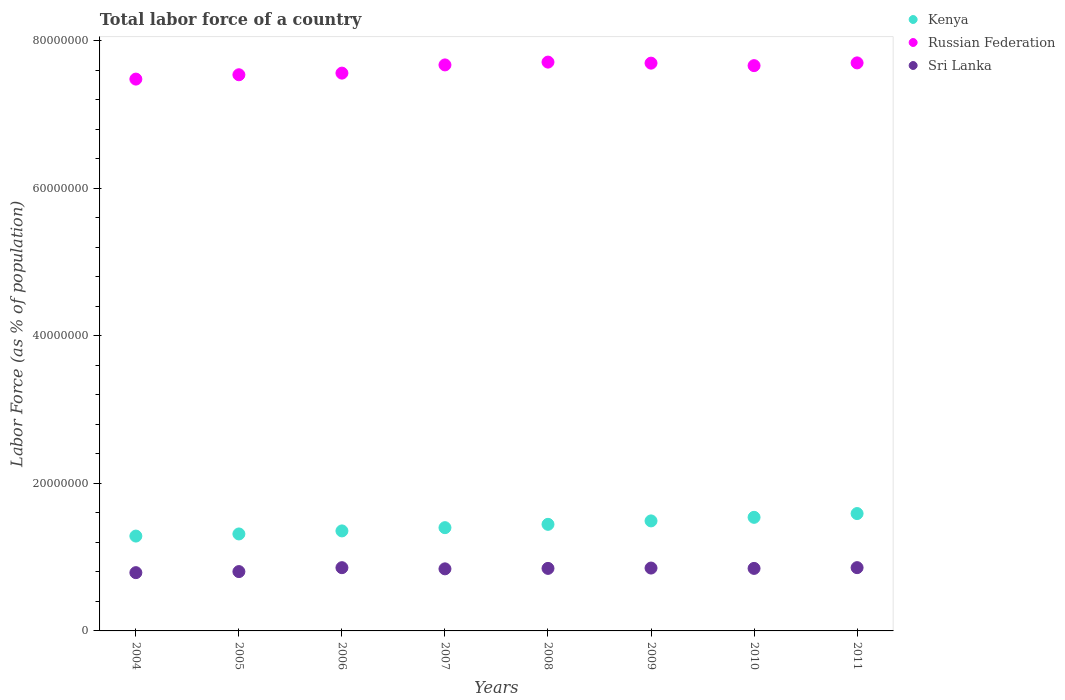How many different coloured dotlines are there?
Your answer should be compact. 3. What is the percentage of labor force in Sri Lanka in 2008?
Your response must be concise. 8.47e+06. Across all years, what is the maximum percentage of labor force in Russian Federation?
Offer a terse response. 7.71e+07. Across all years, what is the minimum percentage of labor force in Sri Lanka?
Your response must be concise. 7.90e+06. What is the total percentage of labor force in Sri Lanka in the graph?
Give a very brief answer. 6.70e+07. What is the difference between the percentage of labor force in Kenya in 2008 and that in 2009?
Offer a terse response. -4.65e+05. What is the difference between the percentage of labor force in Kenya in 2006 and the percentage of labor force in Russian Federation in 2009?
Ensure brevity in your answer.  -6.34e+07. What is the average percentage of labor force in Russian Federation per year?
Give a very brief answer. 7.62e+07. In the year 2011, what is the difference between the percentage of labor force in Kenya and percentage of labor force in Sri Lanka?
Your answer should be compact. 7.33e+06. In how many years, is the percentage of labor force in Sri Lanka greater than 4000000 %?
Provide a short and direct response. 8. What is the ratio of the percentage of labor force in Kenya in 2006 to that in 2007?
Offer a terse response. 0.97. Is the percentage of labor force in Sri Lanka in 2006 less than that in 2010?
Provide a succinct answer. No. Is the difference between the percentage of labor force in Kenya in 2004 and 2008 greater than the difference between the percentage of labor force in Sri Lanka in 2004 and 2008?
Your response must be concise. No. What is the difference between the highest and the second highest percentage of labor force in Russian Federation?
Your answer should be very brief. 1.08e+05. What is the difference between the highest and the lowest percentage of labor force in Russian Federation?
Your answer should be compact. 2.30e+06. Is the sum of the percentage of labor force in Sri Lanka in 2004 and 2011 greater than the maximum percentage of labor force in Kenya across all years?
Offer a terse response. Yes. Is it the case that in every year, the sum of the percentage of labor force in Kenya and percentage of labor force in Sri Lanka  is greater than the percentage of labor force in Russian Federation?
Provide a short and direct response. No. Does the percentage of labor force in Sri Lanka monotonically increase over the years?
Provide a succinct answer. No. Is the percentage of labor force in Russian Federation strictly greater than the percentage of labor force in Kenya over the years?
Make the answer very short. Yes. Is the percentage of labor force in Kenya strictly less than the percentage of labor force in Sri Lanka over the years?
Make the answer very short. No. How many dotlines are there?
Ensure brevity in your answer.  3. How many years are there in the graph?
Provide a succinct answer. 8. Are the values on the major ticks of Y-axis written in scientific E-notation?
Give a very brief answer. No. Does the graph contain any zero values?
Give a very brief answer. No. Does the graph contain grids?
Your answer should be very brief. No. How many legend labels are there?
Your response must be concise. 3. How are the legend labels stacked?
Provide a short and direct response. Vertical. What is the title of the graph?
Provide a short and direct response. Total labor force of a country. What is the label or title of the X-axis?
Your answer should be compact. Years. What is the label or title of the Y-axis?
Keep it short and to the point. Labor Force (as % of population). What is the Labor Force (as % of population) of Kenya in 2004?
Your answer should be very brief. 1.29e+07. What is the Labor Force (as % of population) of Russian Federation in 2004?
Make the answer very short. 7.48e+07. What is the Labor Force (as % of population) in Sri Lanka in 2004?
Make the answer very short. 7.90e+06. What is the Labor Force (as % of population) of Kenya in 2005?
Your answer should be compact. 1.31e+07. What is the Labor Force (as % of population) in Russian Federation in 2005?
Ensure brevity in your answer.  7.54e+07. What is the Labor Force (as % of population) of Sri Lanka in 2005?
Provide a succinct answer. 8.04e+06. What is the Labor Force (as % of population) in Kenya in 2006?
Ensure brevity in your answer.  1.36e+07. What is the Labor Force (as % of population) in Russian Federation in 2006?
Make the answer very short. 7.56e+07. What is the Labor Force (as % of population) in Sri Lanka in 2006?
Your response must be concise. 8.57e+06. What is the Labor Force (as % of population) of Kenya in 2007?
Give a very brief answer. 1.40e+07. What is the Labor Force (as % of population) in Russian Federation in 2007?
Ensure brevity in your answer.  7.67e+07. What is the Labor Force (as % of population) in Sri Lanka in 2007?
Your answer should be compact. 8.41e+06. What is the Labor Force (as % of population) in Kenya in 2008?
Provide a short and direct response. 1.44e+07. What is the Labor Force (as % of population) in Russian Federation in 2008?
Your answer should be very brief. 7.71e+07. What is the Labor Force (as % of population) in Sri Lanka in 2008?
Your answer should be very brief. 8.47e+06. What is the Labor Force (as % of population) of Kenya in 2009?
Provide a succinct answer. 1.49e+07. What is the Labor Force (as % of population) of Russian Federation in 2009?
Offer a terse response. 7.69e+07. What is the Labor Force (as % of population) in Sri Lanka in 2009?
Provide a succinct answer. 8.52e+06. What is the Labor Force (as % of population) of Kenya in 2010?
Your response must be concise. 1.54e+07. What is the Labor Force (as % of population) in Russian Federation in 2010?
Provide a succinct answer. 7.66e+07. What is the Labor Force (as % of population) of Sri Lanka in 2010?
Offer a terse response. 8.47e+06. What is the Labor Force (as % of population) in Kenya in 2011?
Provide a short and direct response. 1.59e+07. What is the Labor Force (as % of population) of Russian Federation in 2011?
Offer a terse response. 7.70e+07. What is the Labor Force (as % of population) of Sri Lanka in 2011?
Provide a short and direct response. 8.57e+06. Across all years, what is the maximum Labor Force (as % of population) of Kenya?
Offer a terse response. 1.59e+07. Across all years, what is the maximum Labor Force (as % of population) of Russian Federation?
Ensure brevity in your answer.  7.71e+07. Across all years, what is the maximum Labor Force (as % of population) in Sri Lanka?
Make the answer very short. 8.57e+06. Across all years, what is the minimum Labor Force (as % of population) of Kenya?
Your answer should be compact. 1.29e+07. Across all years, what is the minimum Labor Force (as % of population) of Russian Federation?
Offer a very short reply. 7.48e+07. Across all years, what is the minimum Labor Force (as % of population) of Sri Lanka?
Offer a terse response. 7.90e+06. What is the total Labor Force (as % of population) of Kenya in the graph?
Your response must be concise. 1.14e+08. What is the total Labor Force (as % of population) of Russian Federation in the graph?
Ensure brevity in your answer.  6.10e+08. What is the total Labor Force (as % of population) in Sri Lanka in the graph?
Make the answer very short. 6.70e+07. What is the difference between the Labor Force (as % of population) in Kenya in 2004 and that in 2005?
Ensure brevity in your answer.  -2.88e+05. What is the difference between the Labor Force (as % of population) of Russian Federation in 2004 and that in 2005?
Your response must be concise. -5.88e+05. What is the difference between the Labor Force (as % of population) in Sri Lanka in 2004 and that in 2005?
Your response must be concise. -1.45e+05. What is the difference between the Labor Force (as % of population) in Kenya in 2004 and that in 2006?
Your response must be concise. -6.99e+05. What is the difference between the Labor Force (as % of population) in Russian Federation in 2004 and that in 2006?
Ensure brevity in your answer.  -8.09e+05. What is the difference between the Labor Force (as % of population) of Sri Lanka in 2004 and that in 2006?
Your answer should be very brief. -6.75e+05. What is the difference between the Labor Force (as % of population) of Kenya in 2004 and that in 2007?
Provide a succinct answer. -1.14e+06. What is the difference between the Labor Force (as % of population) of Russian Federation in 2004 and that in 2007?
Keep it short and to the point. -1.92e+06. What is the difference between the Labor Force (as % of population) in Sri Lanka in 2004 and that in 2007?
Keep it short and to the point. -5.16e+05. What is the difference between the Labor Force (as % of population) of Kenya in 2004 and that in 2008?
Offer a very short reply. -1.59e+06. What is the difference between the Labor Force (as % of population) of Russian Federation in 2004 and that in 2008?
Keep it short and to the point. -2.30e+06. What is the difference between the Labor Force (as % of population) of Sri Lanka in 2004 and that in 2008?
Keep it short and to the point. -5.78e+05. What is the difference between the Labor Force (as % of population) of Kenya in 2004 and that in 2009?
Provide a succinct answer. -2.06e+06. What is the difference between the Labor Force (as % of population) in Russian Federation in 2004 and that in 2009?
Your response must be concise. -2.16e+06. What is the difference between the Labor Force (as % of population) in Sri Lanka in 2004 and that in 2009?
Your answer should be compact. -6.23e+05. What is the difference between the Labor Force (as % of population) of Kenya in 2004 and that in 2010?
Provide a short and direct response. -2.54e+06. What is the difference between the Labor Force (as % of population) of Russian Federation in 2004 and that in 2010?
Ensure brevity in your answer.  -1.82e+06. What is the difference between the Labor Force (as % of population) in Sri Lanka in 2004 and that in 2010?
Offer a very short reply. -5.76e+05. What is the difference between the Labor Force (as % of population) in Kenya in 2004 and that in 2011?
Your answer should be very brief. -3.05e+06. What is the difference between the Labor Force (as % of population) in Russian Federation in 2004 and that in 2011?
Keep it short and to the point. -2.19e+06. What is the difference between the Labor Force (as % of population) of Sri Lanka in 2004 and that in 2011?
Make the answer very short. -6.79e+05. What is the difference between the Labor Force (as % of population) in Kenya in 2005 and that in 2006?
Your answer should be compact. -4.11e+05. What is the difference between the Labor Force (as % of population) in Russian Federation in 2005 and that in 2006?
Provide a succinct answer. -2.22e+05. What is the difference between the Labor Force (as % of population) in Sri Lanka in 2005 and that in 2006?
Provide a succinct answer. -5.30e+05. What is the difference between the Labor Force (as % of population) in Kenya in 2005 and that in 2007?
Your response must be concise. -8.52e+05. What is the difference between the Labor Force (as % of population) in Russian Federation in 2005 and that in 2007?
Provide a succinct answer. -1.33e+06. What is the difference between the Labor Force (as % of population) in Sri Lanka in 2005 and that in 2007?
Make the answer very short. -3.72e+05. What is the difference between the Labor Force (as % of population) in Kenya in 2005 and that in 2008?
Give a very brief answer. -1.30e+06. What is the difference between the Labor Force (as % of population) in Russian Federation in 2005 and that in 2008?
Your answer should be compact. -1.71e+06. What is the difference between the Labor Force (as % of population) in Sri Lanka in 2005 and that in 2008?
Provide a short and direct response. -4.33e+05. What is the difference between the Labor Force (as % of population) of Kenya in 2005 and that in 2009?
Provide a short and direct response. -1.77e+06. What is the difference between the Labor Force (as % of population) of Russian Federation in 2005 and that in 2009?
Offer a terse response. -1.57e+06. What is the difference between the Labor Force (as % of population) of Sri Lanka in 2005 and that in 2009?
Make the answer very short. -4.78e+05. What is the difference between the Labor Force (as % of population) of Kenya in 2005 and that in 2010?
Make the answer very short. -2.25e+06. What is the difference between the Labor Force (as % of population) in Russian Federation in 2005 and that in 2010?
Give a very brief answer. -1.24e+06. What is the difference between the Labor Force (as % of population) in Sri Lanka in 2005 and that in 2010?
Provide a short and direct response. -4.31e+05. What is the difference between the Labor Force (as % of population) of Kenya in 2005 and that in 2011?
Make the answer very short. -2.76e+06. What is the difference between the Labor Force (as % of population) of Russian Federation in 2005 and that in 2011?
Ensure brevity in your answer.  -1.61e+06. What is the difference between the Labor Force (as % of population) in Sri Lanka in 2005 and that in 2011?
Provide a succinct answer. -5.35e+05. What is the difference between the Labor Force (as % of population) of Kenya in 2006 and that in 2007?
Keep it short and to the point. -4.41e+05. What is the difference between the Labor Force (as % of population) of Russian Federation in 2006 and that in 2007?
Your response must be concise. -1.11e+06. What is the difference between the Labor Force (as % of population) in Sri Lanka in 2006 and that in 2007?
Provide a succinct answer. 1.58e+05. What is the difference between the Labor Force (as % of population) of Kenya in 2006 and that in 2008?
Your answer should be very brief. -8.92e+05. What is the difference between the Labor Force (as % of population) of Russian Federation in 2006 and that in 2008?
Offer a terse response. -1.49e+06. What is the difference between the Labor Force (as % of population) in Sri Lanka in 2006 and that in 2008?
Provide a short and direct response. 9.71e+04. What is the difference between the Labor Force (as % of population) in Kenya in 2006 and that in 2009?
Make the answer very short. -1.36e+06. What is the difference between the Labor Force (as % of population) in Russian Federation in 2006 and that in 2009?
Your answer should be compact. -1.35e+06. What is the difference between the Labor Force (as % of population) in Sri Lanka in 2006 and that in 2009?
Offer a very short reply. 5.17e+04. What is the difference between the Labor Force (as % of population) of Kenya in 2006 and that in 2010?
Offer a very short reply. -1.84e+06. What is the difference between the Labor Force (as % of population) of Russian Federation in 2006 and that in 2010?
Your answer should be compact. -1.01e+06. What is the difference between the Labor Force (as % of population) of Sri Lanka in 2006 and that in 2010?
Your answer should be compact. 9.89e+04. What is the difference between the Labor Force (as % of population) of Kenya in 2006 and that in 2011?
Ensure brevity in your answer.  -2.35e+06. What is the difference between the Labor Force (as % of population) of Russian Federation in 2006 and that in 2011?
Offer a terse response. -1.39e+06. What is the difference between the Labor Force (as % of population) of Sri Lanka in 2006 and that in 2011?
Ensure brevity in your answer.  -4398. What is the difference between the Labor Force (as % of population) in Kenya in 2007 and that in 2008?
Offer a terse response. -4.51e+05. What is the difference between the Labor Force (as % of population) of Russian Federation in 2007 and that in 2008?
Give a very brief answer. -3.81e+05. What is the difference between the Labor Force (as % of population) of Sri Lanka in 2007 and that in 2008?
Provide a short and direct response. -6.13e+04. What is the difference between the Labor Force (as % of population) of Kenya in 2007 and that in 2009?
Keep it short and to the point. -9.16e+05. What is the difference between the Labor Force (as % of population) in Russian Federation in 2007 and that in 2009?
Your answer should be very brief. -2.40e+05. What is the difference between the Labor Force (as % of population) of Sri Lanka in 2007 and that in 2009?
Provide a short and direct response. -1.07e+05. What is the difference between the Labor Force (as % of population) of Kenya in 2007 and that in 2010?
Ensure brevity in your answer.  -1.40e+06. What is the difference between the Labor Force (as % of population) of Russian Federation in 2007 and that in 2010?
Give a very brief answer. 9.79e+04. What is the difference between the Labor Force (as % of population) in Sri Lanka in 2007 and that in 2010?
Offer a very short reply. -5.95e+04. What is the difference between the Labor Force (as % of population) of Kenya in 2007 and that in 2011?
Ensure brevity in your answer.  -1.91e+06. What is the difference between the Labor Force (as % of population) in Russian Federation in 2007 and that in 2011?
Keep it short and to the point. -2.74e+05. What is the difference between the Labor Force (as % of population) in Sri Lanka in 2007 and that in 2011?
Give a very brief answer. -1.63e+05. What is the difference between the Labor Force (as % of population) of Kenya in 2008 and that in 2009?
Keep it short and to the point. -4.65e+05. What is the difference between the Labor Force (as % of population) in Russian Federation in 2008 and that in 2009?
Offer a terse response. 1.41e+05. What is the difference between the Labor Force (as % of population) of Sri Lanka in 2008 and that in 2009?
Ensure brevity in your answer.  -4.54e+04. What is the difference between the Labor Force (as % of population) of Kenya in 2008 and that in 2010?
Provide a short and direct response. -9.49e+05. What is the difference between the Labor Force (as % of population) of Russian Federation in 2008 and that in 2010?
Make the answer very short. 4.79e+05. What is the difference between the Labor Force (as % of population) in Sri Lanka in 2008 and that in 2010?
Ensure brevity in your answer.  1805. What is the difference between the Labor Force (as % of population) in Kenya in 2008 and that in 2011?
Offer a very short reply. -1.46e+06. What is the difference between the Labor Force (as % of population) of Russian Federation in 2008 and that in 2011?
Your response must be concise. 1.08e+05. What is the difference between the Labor Force (as % of population) in Sri Lanka in 2008 and that in 2011?
Provide a succinct answer. -1.02e+05. What is the difference between the Labor Force (as % of population) in Kenya in 2009 and that in 2010?
Provide a short and direct response. -4.84e+05. What is the difference between the Labor Force (as % of population) of Russian Federation in 2009 and that in 2010?
Your answer should be very brief. 3.38e+05. What is the difference between the Labor Force (as % of population) of Sri Lanka in 2009 and that in 2010?
Offer a very short reply. 4.72e+04. What is the difference between the Labor Force (as % of population) in Kenya in 2009 and that in 2011?
Ensure brevity in your answer.  -9.95e+05. What is the difference between the Labor Force (as % of population) in Russian Federation in 2009 and that in 2011?
Offer a terse response. -3.38e+04. What is the difference between the Labor Force (as % of population) in Sri Lanka in 2009 and that in 2011?
Offer a terse response. -5.61e+04. What is the difference between the Labor Force (as % of population) of Kenya in 2010 and that in 2011?
Provide a short and direct response. -5.11e+05. What is the difference between the Labor Force (as % of population) of Russian Federation in 2010 and that in 2011?
Your response must be concise. -3.72e+05. What is the difference between the Labor Force (as % of population) in Sri Lanka in 2010 and that in 2011?
Make the answer very short. -1.03e+05. What is the difference between the Labor Force (as % of population) in Kenya in 2004 and the Labor Force (as % of population) in Russian Federation in 2005?
Offer a terse response. -6.25e+07. What is the difference between the Labor Force (as % of population) of Kenya in 2004 and the Labor Force (as % of population) of Sri Lanka in 2005?
Your response must be concise. 4.81e+06. What is the difference between the Labor Force (as % of population) in Russian Federation in 2004 and the Labor Force (as % of population) in Sri Lanka in 2005?
Give a very brief answer. 6.67e+07. What is the difference between the Labor Force (as % of population) in Kenya in 2004 and the Labor Force (as % of population) in Russian Federation in 2006?
Offer a very short reply. -6.27e+07. What is the difference between the Labor Force (as % of population) in Kenya in 2004 and the Labor Force (as % of population) in Sri Lanka in 2006?
Give a very brief answer. 4.28e+06. What is the difference between the Labor Force (as % of population) of Russian Federation in 2004 and the Labor Force (as % of population) of Sri Lanka in 2006?
Provide a short and direct response. 6.62e+07. What is the difference between the Labor Force (as % of population) of Kenya in 2004 and the Labor Force (as % of population) of Russian Federation in 2007?
Your answer should be very brief. -6.38e+07. What is the difference between the Labor Force (as % of population) of Kenya in 2004 and the Labor Force (as % of population) of Sri Lanka in 2007?
Offer a very short reply. 4.44e+06. What is the difference between the Labor Force (as % of population) in Russian Federation in 2004 and the Labor Force (as % of population) in Sri Lanka in 2007?
Give a very brief answer. 6.64e+07. What is the difference between the Labor Force (as % of population) of Kenya in 2004 and the Labor Force (as % of population) of Russian Federation in 2008?
Ensure brevity in your answer.  -6.42e+07. What is the difference between the Labor Force (as % of population) in Kenya in 2004 and the Labor Force (as % of population) in Sri Lanka in 2008?
Give a very brief answer. 4.38e+06. What is the difference between the Labor Force (as % of population) in Russian Federation in 2004 and the Labor Force (as % of population) in Sri Lanka in 2008?
Your answer should be very brief. 6.63e+07. What is the difference between the Labor Force (as % of population) in Kenya in 2004 and the Labor Force (as % of population) in Russian Federation in 2009?
Your answer should be compact. -6.41e+07. What is the difference between the Labor Force (as % of population) in Kenya in 2004 and the Labor Force (as % of population) in Sri Lanka in 2009?
Ensure brevity in your answer.  4.33e+06. What is the difference between the Labor Force (as % of population) of Russian Federation in 2004 and the Labor Force (as % of population) of Sri Lanka in 2009?
Give a very brief answer. 6.63e+07. What is the difference between the Labor Force (as % of population) in Kenya in 2004 and the Labor Force (as % of population) in Russian Federation in 2010?
Your response must be concise. -6.37e+07. What is the difference between the Labor Force (as % of population) of Kenya in 2004 and the Labor Force (as % of population) of Sri Lanka in 2010?
Your answer should be compact. 4.38e+06. What is the difference between the Labor Force (as % of population) of Russian Federation in 2004 and the Labor Force (as % of population) of Sri Lanka in 2010?
Your response must be concise. 6.63e+07. What is the difference between the Labor Force (as % of population) of Kenya in 2004 and the Labor Force (as % of population) of Russian Federation in 2011?
Provide a succinct answer. -6.41e+07. What is the difference between the Labor Force (as % of population) in Kenya in 2004 and the Labor Force (as % of population) in Sri Lanka in 2011?
Ensure brevity in your answer.  4.28e+06. What is the difference between the Labor Force (as % of population) of Russian Federation in 2004 and the Labor Force (as % of population) of Sri Lanka in 2011?
Ensure brevity in your answer.  6.62e+07. What is the difference between the Labor Force (as % of population) in Kenya in 2005 and the Labor Force (as % of population) in Russian Federation in 2006?
Provide a short and direct response. -6.24e+07. What is the difference between the Labor Force (as % of population) in Kenya in 2005 and the Labor Force (as % of population) in Sri Lanka in 2006?
Your response must be concise. 4.57e+06. What is the difference between the Labor Force (as % of population) in Russian Federation in 2005 and the Labor Force (as % of population) in Sri Lanka in 2006?
Your answer should be compact. 6.68e+07. What is the difference between the Labor Force (as % of population) in Kenya in 2005 and the Labor Force (as % of population) in Russian Federation in 2007?
Offer a terse response. -6.36e+07. What is the difference between the Labor Force (as % of population) in Kenya in 2005 and the Labor Force (as % of population) in Sri Lanka in 2007?
Keep it short and to the point. 4.73e+06. What is the difference between the Labor Force (as % of population) of Russian Federation in 2005 and the Labor Force (as % of population) of Sri Lanka in 2007?
Ensure brevity in your answer.  6.69e+07. What is the difference between the Labor Force (as % of population) of Kenya in 2005 and the Labor Force (as % of population) of Russian Federation in 2008?
Your response must be concise. -6.39e+07. What is the difference between the Labor Force (as % of population) of Kenya in 2005 and the Labor Force (as % of population) of Sri Lanka in 2008?
Provide a short and direct response. 4.67e+06. What is the difference between the Labor Force (as % of population) of Russian Federation in 2005 and the Labor Force (as % of population) of Sri Lanka in 2008?
Ensure brevity in your answer.  6.69e+07. What is the difference between the Labor Force (as % of population) in Kenya in 2005 and the Labor Force (as % of population) in Russian Federation in 2009?
Give a very brief answer. -6.38e+07. What is the difference between the Labor Force (as % of population) in Kenya in 2005 and the Labor Force (as % of population) in Sri Lanka in 2009?
Provide a short and direct response. 4.62e+06. What is the difference between the Labor Force (as % of population) of Russian Federation in 2005 and the Labor Force (as % of population) of Sri Lanka in 2009?
Offer a terse response. 6.68e+07. What is the difference between the Labor Force (as % of population) in Kenya in 2005 and the Labor Force (as % of population) in Russian Federation in 2010?
Provide a short and direct response. -6.35e+07. What is the difference between the Labor Force (as % of population) in Kenya in 2005 and the Labor Force (as % of population) in Sri Lanka in 2010?
Keep it short and to the point. 4.67e+06. What is the difference between the Labor Force (as % of population) of Russian Federation in 2005 and the Labor Force (as % of population) of Sri Lanka in 2010?
Keep it short and to the point. 6.69e+07. What is the difference between the Labor Force (as % of population) in Kenya in 2005 and the Labor Force (as % of population) in Russian Federation in 2011?
Offer a terse response. -6.38e+07. What is the difference between the Labor Force (as % of population) in Kenya in 2005 and the Labor Force (as % of population) in Sri Lanka in 2011?
Make the answer very short. 4.56e+06. What is the difference between the Labor Force (as % of population) of Russian Federation in 2005 and the Labor Force (as % of population) of Sri Lanka in 2011?
Offer a very short reply. 6.68e+07. What is the difference between the Labor Force (as % of population) of Kenya in 2006 and the Labor Force (as % of population) of Russian Federation in 2007?
Keep it short and to the point. -6.31e+07. What is the difference between the Labor Force (as % of population) of Kenya in 2006 and the Labor Force (as % of population) of Sri Lanka in 2007?
Offer a very short reply. 5.14e+06. What is the difference between the Labor Force (as % of population) of Russian Federation in 2006 and the Labor Force (as % of population) of Sri Lanka in 2007?
Make the answer very short. 6.72e+07. What is the difference between the Labor Force (as % of population) of Kenya in 2006 and the Labor Force (as % of population) of Russian Federation in 2008?
Provide a short and direct response. -6.35e+07. What is the difference between the Labor Force (as % of population) in Kenya in 2006 and the Labor Force (as % of population) in Sri Lanka in 2008?
Your answer should be compact. 5.08e+06. What is the difference between the Labor Force (as % of population) of Russian Federation in 2006 and the Labor Force (as % of population) of Sri Lanka in 2008?
Provide a succinct answer. 6.71e+07. What is the difference between the Labor Force (as % of population) in Kenya in 2006 and the Labor Force (as % of population) in Russian Federation in 2009?
Give a very brief answer. -6.34e+07. What is the difference between the Labor Force (as % of population) in Kenya in 2006 and the Labor Force (as % of population) in Sri Lanka in 2009?
Your response must be concise. 5.03e+06. What is the difference between the Labor Force (as % of population) of Russian Federation in 2006 and the Labor Force (as % of population) of Sri Lanka in 2009?
Your answer should be very brief. 6.71e+07. What is the difference between the Labor Force (as % of population) in Kenya in 2006 and the Labor Force (as % of population) in Russian Federation in 2010?
Give a very brief answer. -6.30e+07. What is the difference between the Labor Force (as % of population) of Kenya in 2006 and the Labor Force (as % of population) of Sri Lanka in 2010?
Your answer should be very brief. 5.08e+06. What is the difference between the Labor Force (as % of population) of Russian Federation in 2006 and the Labor Force (as % of population) of Sri Lanka in 2010?
Your answer should be very brief. 6.71e+07. What is the difference between the Labor Force (as % of population) of Kenya in 2006 and the Labor Force (as % of population) of Russian Federation in 2011?
Ensure brevity in your answer.  -6.34e+07. What is the difference between the Labor Force (as % of population) in Kenya in 2006 and the Labor Force (as % of population) in Sri Lanka in 2011?
Offer a very short reply. 4.98e+06. What is the difference between the Labor Force (as % of population) in Russian Federation in 2006 and the Labor Force (as % of population) in Sri Lanka in 2011?
Give a very brief answer. 6.70e+07. What is the difference between the Labor Force (as % of population) in Kenya in 2007 and the Labor Force (as % of population) in Russian Federation in 2008?
Ensure brevity in your answer.  -6.31e+07. What is the difference between the Labor Force (as % of population) in Kenya in 2007 and the Labor Force (as % of population) in Sri Lanka in 2008?
Ensure brevity in your answer.  5.52e+06. What is the difference between the Labor Force (as % of population) of Russian Federation in 2007 and the Labor Force (as % of population) of Sri Lanka in 2008?
Provide a short and direct response. 6.82e+07. What is the difference between the Labor Force (as % of population) of Kenya in 2007 and the Labor Force (as % of population) of Russian Federation in 2009?
Ensure brevity in your answer.  -6.29e+07. What is the difference between the Labor Force (as % of population) of Kenya in 2007 and the Labor Force (as % of population) of Sri Lanka in 2009?
Keep it short and to the point. 5.47e+06. What is the difference between the Labor Force (as % of population) in Russian Federation in 2007 and the Labor Force (as % of population) in Sri Lanka in 2009?
Ensure brevity in your answer.  6.82e+07. What is the difference between the Labor Force (as % of population) in Kenya in 2007 and the Labor Force (as % of population) in Russian Federation in 2010?
Your answer should be compact. -6.26e+07. What is the difference between the Labor Force (as % of population) of Kenya in 2007 and the Labor Force (as % of population) of Sri Lanka in 2010?
Your answer should be very brief. 5.52e+06. What is the difference between the Labor Force (as % of population) in Russian Federation in 2007 and the Labor Force (as % of population) in Sri Lanka in 2010?
Give a very brief answer. 6.82e+07. What is the difference between the Labor Force (as % of population) in Kenya in 2007 and the Labor Force (as % of population) in Russian Federation in 2011?
Make the answer very short. -6.30e+07. What is the difference between the Labor Force (as % of population) of Kenya in 2007 and the Labor Force (as % of population) of Sri Lanka in 2011?
Your response must be concise. 5.42e+06. What is the difference between the Labor Force (as % of population) in Russian Federation in 2007 and the Labor Force (as % of population) in Sri Lanka in 2011?
Make the answer very short. 6.81e+07. What is the difference between the Labor Force (as % of population) of Kenya in 2008 and the Labor Force (as % of population) of Russian Federation in 2009?
Ensure brevity in your answer.  -6.25e+07. What is the difference between the Labor Force (as % of population) in Kenya in 2008 and the Labor Force (as % of population) in Sri Lanka in 2009?
Offer a terse response. 5.92e+06. What is the difference between the Labor Force (as % of population) in Russian Federation in 2008 and the Labor Force (as % of population) in Sri Lanka in 2009?
Your response must be concise. 6.86e+07. What is the difference between the Labor Force (as % of population) of Kenya in 2008 and the Labor Force (as % of population) of Russian Federation in 2010?
Keep it short and to the point. -6.22e+07. What is the difference between the Labor Force (as % of population) of Kenya in 2008 and the Labor Force (as % of population) of Sri Lanka in 2010?
Make the answer very short. 5.97e+06. What is the difference between the Labor Force (as % of population) of Russian Federation in 2008 and the Labor Force (as % of population) of Sri Lanka in 2010?
Your response must be concise. 6.86e+07. What is the difference between the Labor Force (as % of population) in Kenya in 2008 and the Labor Force (as % of population) in Russian Federation in 2011?
Provide a short and direct response. -6.25e+07. What is the difference between the Labor Force (as % of population) in Kenya in 2008 and the Labor Force (as % of population) in Sri Lanka in 2011?
Your answer should be compact. 5.87e+06. What is the difference between the Labor Force (as % of population) in Russian Federation in 2008 and the Labor Force (as % of population) in Sri Lanka in 2011?
Ensure brevity in your answer.  6.85e+07. What is the difference between the Labor Force (as % of population) in Kenya in 2009 and the Labor Force (as % of population) in Russian Federation in 2010?
Your answer should be compact. -6.17e+07. What is the difference between the Labor Force (as % of population) of Kenya in 2009 and the Labor Force (as % of population) of Sri Lanka in 2010?
Make the answer very short. 6.44e+06. What is the difference between the Labor Force (as % of population) of Russian Federation in 2009 and the Labor Force (as % of population) of Sri Lanka in 2010?
Offer a terse response. 6.85e+07. What is the difference between the Labor Force (as % of population) in Kenya in 2009 and the Labor Force (as % of population) in Russian Federation in 2011?
Give a very brief answer. -6.21e+07. What is the difference between the Labor Force (as % of population) of Kenya in 2009 and the Labor Force (as % of population) of Sri Lanka in 2011?
Your answer should be very brief. 6.33e+06. What is the difference between the Labor Force (as % of population) of Russian Federation in 2009 and the Labor Force (as % of population) of Sri Lanka in 2011?
Your answer should be very brief. 6.84e+07. What is the difference between the Labor Force (as % of population) of Kenya in 2010 and the Labor Force (as % of population) of Russian Federation in 2011?
Offer a terse response. -6.16e+07. What is the difference between the Labor Force (as % of population) of Kenya in 2010 and the Labor Force (as % of population) of Sri Lanka in 2011?
Offer a terse response. 6.82e+06. What is the difference between the Labor Force (as % of population) in Russian Federation in 2010 and the Labor Force (as % of population) in Sri Lanka in 2011?
Offer a very short reply. 6.80e+07. What is the average Labor Force (as % of population) of Kenya per year?
Offer a terse response. 1.43e+07. What is the average Labor Force (as % of population) in Russian Federation per year?
Provide a short and direct response. 7.62e+07. What is the average Labor Force (as % of population) of Sri Lanka per year?
Give a very brief answer. 8.37e+06. In the year 2004, what is the difference between the Labor Force (as % of population) of Kenya and Labor Force (as % of population) of Russian Federation?
Give a very brief answer. -6.19e+07. In the year 2004, what is the difference between the Labor Force (as % of population) in Kenya and Labor Force (as % of population) in Sri Lanka?
Provide a short and direct response. 4.96e+06. In the year 2004, what is the difference between the Labor Force (as % of population) in Russian Federation and Labor Force (as % of population) in Sri Lanka?
Offer a very short reply. 6.69e+07. In the year 2005, what is the difference between the Labor Force (as % of population) in Kenya and Labor Force (as % of population) in Russian Federation?
Keep it short and to the point. -6.22e+07. In the year 2005, what is the difference between the Labor Force (as % of population) in Kenya and Labor Force (as % of population) in Sri Lanka?
Your answer should be compact. 5.10e+06. In the year 2005, what is the difference between the Labor Force (as % of population) in Russian Federation and Labor Force (as % of population) in Sri Lanka?
Ensure brevity in your answer.  6.73e+07. In the year 2006, what is the difference between the Labor Force (as % of population) of Kenya and Labor Force (as % of population) of Russian Federation?
Offer a very short reply. -6.20e+07. In the year 2006, what is the difference between the Labor Force (as % of population) in Kenya and Labor Force (as % of population) in Sri Lanka?
Your answer should be compact. 4.98e+06. In the year 2006, what is the difference between the Labor Force (as % of population) in Russian Federation and Labor Force (as % of population) in Sri Lanka?
Give a very brief answer. 6.70e+07. In the year 2007, what is the difference between the Labor Force (as % of population) of Kenya and Labor Force (as % of population) of Russian Federation?
Your response must be concise. -6.27e+07. In the year 2007, what is the difference between the Labor Force (as % of population) in Kenya and Labor Force (as % of population) in Sri Lanka?
Offer a very short reply. 5.58e+06. In the year 2007, what is the difference between the Labor Force (as % of population) of Russian Federation and Labor Force (as % of population) of Sri Lanka?
Offer a very short reply. 6.83e+07. In the year 2008, what is the difference between the Labor Force (as % of population) of Kenya and Labor Force (as % of population) of Russian Federation?
Offer a very short reply. -6.26e+07. In the year 2008, what is the difference between the Labor Force (as % of population) in Kenya and Labor Force (as % of population) in Sri Lanka?
Make the answer very short. 5.97e+06. In the year 2008, what is the difference between the Labor Force (as % of population) of Russian Federation and Labor Force (as % of population) of Sri Lanka?
Make the answer very short. 6.86e+07. In the year 2009, what is the difference between the Labor Force (as % of population) of Kenya and Labor Force (as % of population) of Russian Federation?
Offer a terse response. -6.20e+07. In the year 2009, what is the difference between the Labor Force (as % of population) of Kenya and Labor Force (as % of population) of Sri Lanka?
Offer a very short reply. 6.39e+06. In the year 2009, what is the difference between the Labor Force (as % of population) of Russian Federation and Labor Force (as % of population) of Sri Lanka?
Ensure brevity in your answer.  6.84e+07. In the year 2010, what is the difference between the Labor Force (as % of population) of Kenya and Labor Force (as % of population) of Russian Federation?
Your answer should be very brief. -6.12e+07. In the year 2010, what is the difference between the Labor Force (as % of population) in Kenya and Labor Force (as % of population) in Sri Lanka?
Keep it short and to the point. 6.92e+06. In the year 2010, what is the difference between the Labor Force (as % of population) of Russian Federation and Labor Force (as % of population) of Sri Lanka?
Provide a succinct answer. 6.81e+07. In the year 2011, what is the difference between the Labor Force (as % of population) of Kenya and Labor Force (as % of population) of Russian Federation?
Provide a short and direct response. -6.11e+07. In the year 2011, what is the difference between the Labor Force (as % of population) in Kenya and Labor Force (as % of population) in Sri Lanka?
Provide a succinct answer. 7.33e+06. In the year 2011, what is the difference between the Labor Force (as % of population) of Russian Federation and Labor Force (as % of population) of Sri Lanka?
Offer a very short reply. 6.84e+07. What is the ratio of the Labor Force (as % of population) in Kenya in 2004 to that in 2005?
Your response must be concise. 0.98. What is the ratio of the Labor Force (as % of population) in Russian Federation in 2004 to that in 2005?
Keep it short and to the point. 0.99. What is the ratio of the Labor Force (as % of population) in Sri Lanka in 2004 to that in 2005?
Your response must be concise. 0.98. What is the ratio of the Labor Force (as % of population) in Kenya in 2004 to that in 2006?
Offer a terse response. 0.95. What is the ratio of the Labor Force (as % of population) of Russian Federation in 2004 to that in 2006?
Ensure brevity in your answer.  0.99. What is the ratio of the Labor Force (as % of population) in Sri Lanka in 2004 to that in 2006?
Your answer should be very brief. 0.92. What is the ratio of the Labor Force (as % of population) in Kenya in 2004 to that in 2007?
Keep it short and to the point. 0.92. What is the ratio of the Labor Force (as % of population) in Sri Lanka in 2004 to that in 2007?
Your response must be concise. 0.94. What is the ratio of the Labor Force (as % of population) in Kenya in 2004 to that in 2008?
Keep it short and to the point. 0.89. What is the ratio of the Labor Force (as % of population) in Russian Federation in 2004 to that in 2008?
Ensure brevity in your answer.  0.97. What is the ratio of the Labor Force (as % of population) in Sri Lanka in 2004 to that in 2008?
Offer a very short reply. 0.93. What is the ratio of the Labor Force (as % of population) in Kenya in 2004 to that in 2009?
Your answer should be compact. 0.86. What is the ratio of the Labor Force (as % of population) of Russian Federation in 2004 to that in 2009?
Your response must be concise. 0.97. What is the ratio of the Labor Force (as % of population) of Sri Lanka in 2004 to that in 2009?
Your response must be concise. 0.93. What is the ratio of the Labor Force (as % of population) of Kenya in 2004 to that in 2010?
Make the answer very short. 0.83. What is the ratio of the Labor Force (as % of population) in Russian Federation in 2004 to that in 2010?
Your response must be concise. 0.98. What is the ratio of the Labor Force (as % of population) of Sri Lanka in 2004 to that in 2010?
Keep it short and to the point. 0.93. What is the ratio of the Labor Force (as % of population) of Kenya in 2004 to that in 2011?
Provide a succinct answer. 0.81. What is the ratio of the Labor Force (as % of population) of Russian Federation in 2004 to that in 2011?
Provide a short and direct response. 0.97. What is the ratio of the Labor Force (as % of population) of Sri Lanka in 2004 to that in 2011?
Offer a terse response. 0.92. What is the ratio of the Labor Force (as % of population) of Kenya in 2005 to that in 2006?
Offer a terse response. 0.97. What is the ratio of the Labor Force (as % of population) of Sri Lanka in 2005 to that in 2006?
Ensure brevity in your answer.  0.94. What is the ratio of the Labor Force (as % of population) of Kenya in 2005 to that in 2007?
Provide a short and direct response. 0.94. What is the ratio of the Labor Force (as % of population) in Russian Federation in 2005 to that in 2007?
Provide a succinct answer. 0.98. What is the ratio of the Labor Force (as % of population) of Sri Lanka in 2005 to that in 2007?
Make the answer very short. 0.96. What is the ratio of the Labor Force (as % of population) in Kenya in 2005 to that in 2008?
Offer a terse response. 0.91. What is the ratio of the Labor Force (as % of population) of Russian Federation in 2005 to that in 2008?
Keep it short and to the point. 0.98. What is the ratio of the Labor Force (as % of population) of Sri Lanka in 2005 to that in 2008?
Give a very brief answer. 0.95. What is the ratio of the Labor Force (as % of population) of Kenya in 2005 to that in 2009?
Provide a succinct answer. 0.88. What is the ratio of the Labor Force (as % of population) in Russian Federation in 2005 to that in 2009?
Your answer should be compact. 0.98. What is the ratio of the Labor Force (as % of population) of Sri Lanka in 2005 to that in 2009?
Give a very brief answer. 0.94. What is the ratio of the Labor Force (as % of population) in Kenya in 2005 to that in 2010?
Make the answer very short. 0.85. What is the ratio of the Labor Force (as % of population) of Russian Federation in 2005 to that in 2010?
Keep it short and to the point. 0.98. What is the ratio of the Labor Force (as % of population) in Sri Lanka in 2005 to that in 2010?
Your answer should be compact. 0.95. What is the ratio of the Labor Force (as % of population) in Kenya in 2005 to that in 2011?
Provide a short and direct response. 0.83. What is the ratio of the Labor Force (as % of population) in Russian Federation in 2005 to that in 2011?
Provide a short and direct response. 0.98. What is the ratio of the Labor Force (as % of population) of Sri Lanka in 2005 to that in 2011?
Offer a terse response. 0.94. What is the ratio of the Labor Force (as % of population) in Kenya in 2006 to that in 2007?
Your answer should be very brief. 0.97. What is the ratio of the Labor Force (as % of population) in Russian Federation in 2006 to that in 2007?
Your response must be concise. 0.99. What is the ratio of the Labor Force (as % of population) in Sri Lanka in 2006 to that in 2007?
Make the answer very short. 1.02. What is the ratio of the Labor Force (as % of population) of Kenya in 2006 to that in 2008?
Your answer should be very brief. 0.94. What is the ratio of the Labor Force (as % of population) of Russian Federation in 2006 to that in 2008?
Ensure brevity in your answer.  0.98. What is the ratio of the Labor Force (as % of population) of Sri Lanka in 2006 to that in 2008?
Your response must be concise. 1.01. What is the ratio of the Labor Force (as % of population) in Kenya in 2006 to that in 2009?
Make the answer very short. 0.91. What is the ratio of the Labor Force (as % of population) of Russian Federation in 2006 to that in 2009?
Offer a very short reply. 0.98. What is the ratio of the Labor Force (as % of population) of Sri Lanka in 2006 to that in 2009?
Your answer should be very brief. 1.01. What is the ratio of the Labor Force (as % of population) of Kenya in 2006 to that in 2010?
Give a very brief answer. 0.88. What is the ratio of the Labor Force (as % of population) in Russian Federation in 2006 to that in 2010?
Offer a terse response. 0.99. What is the ratio of the Labor Force (as % of population) of Sri Lanka in 2006 to that in 2010?
Offer a very short reply. 1.01. What is the ratio of the Labor Force (as % of population) of Kenya in 2006 to that in 2011?
Offer a terse response. 0.85. What is the ratio of the Labor Force (as % of population) of Sri Lanka in 2006 to that in 2011?
Your answer should be compact. 1. What is the ratio of the Labor Force (as % of population) in Kenya in 2007 to that in 2008?
Your response must be concise. 0.97. What is the ratio of the Labor Force (as % of population) in Kenya in 2007 to that in 2009?
Give a very brief answer. 0.94. What is the ratio of the Labor Force (as % of population) in Sri Lanka in 2007 to that in 2009?
Your response must be concise. 0.99. What is the ratio of the Labor Force (as % of population) in Kenya in 2007 to that in 2010?
Ensure brevity in your answer.  0.91. What is the ratio of the Labor Force (as % of population) in Sri Lanka in 2007 to that in 2010?
Ensure brevity in your answer.  0.99. What is the ratio of the Labor Force (as % of population) of Kenya in 2007 to that in 2011?
Offer a very short reply. 0.88. What is the ratio of the Labor Force (as % of population) in Russian Federation in 2007 to that in 2011?
Provide a short and direct response. 1. What is the ratio of the Labor Force (as % of population) of Sri Lanka in 2007 to that in 2011?
Make the answer very short. 0.98. What is the ratio of the Labor Force (as % of population) of Kenya in 2008 to that in 2009?
Offer a very short reply. 0.97. What is the ratio of the Labor Force (as % of population) in Russian Federation in 2008 to that in 2009?
Provide a succinct answer. 1. What is the ratio of the Labor Force (as % of population) in Sri Lanka in 2008 to that in 2009?
Make the answer very short. 0.99. What is the ratio of the Labor Force (as % of population) of Kenya in 2008 to that in 2010?
Your response must be concise. 0.94. What is the ratio of the Labor Force (as % of population) of Russian Federation in 2008 to that in 2010?
Your response must be concise. 1.01. What is the ratio of the Labor Force (as % of population) in Sri Lanka in 2008 to that in 2010?
Keep it short and to the point. 1. What is the ratio of the Labor Force (as % of population) of Kenya in 2008 to that in 2011?
Give a very brief answer. 0.91. What is the ratio of the Labor Force (as % of population) in Sri Lanka in 2008 to that in 2011?
Offer a terse response. 0.99. What is the ratio of the Labor Force (as % of population) in Kenya in 2009 to that in 2010?
Ensure brevity in your answer.  0.97. What is the ratio of the Labor Force (as % of population) of Sri Lanka in 2009 to that in 2010?
Make the answer very short. 1.01. What is the ratio of the Labor Force (as % of population) of Kenya in 2009 to that in 2011?
Make the answer very short. 0.94. What is the ratio of the Labor Force (as % of population) of Russian Federation in 2009 to that in 2011?
Offer a terse response. 1. What is the ratio of the Labor Force (as % of population) in Sri Lanka in 2009 to that in 2011?
Your response must be concise. 0.99. What is the ratio of the Labor Force (as % of population) of Kenya in 2010 to that in 2011?
Ensure brevity in your answer.  0.97. What is the ratio of the Labor Force (as % of population) of Sri Lanka in 2010 to that in 2011?
Offer a terse response. 0.99. What is the difference between the highest and the second highest Labor Force (as % of population) of Kenya?
Provide a short and direct response. 5.11e+05. What is the difference between the highest and the second highest Labor Force (as % of population) in Russian Federation?
Your response must be concise. 1.08e+05. What is the difference between the highest and the second highest Labor Force (as % of population) in Sri Lanka?
Your answer should be compact. 4398. What is the difference between the highest and the lowest Labor Force (as % of population) in Kenya?
Offer a terse response. 3.05e+06. What is the difference between the highest and the lowest Labor Force (as % of population) in Russian Federation?
Make the answer very short. 2.30e+06. What is the difference between the highest and the lowest Labor Force (as % of population) in Sri Lanka?
Your answer should be very brief. 6.79e+05. 